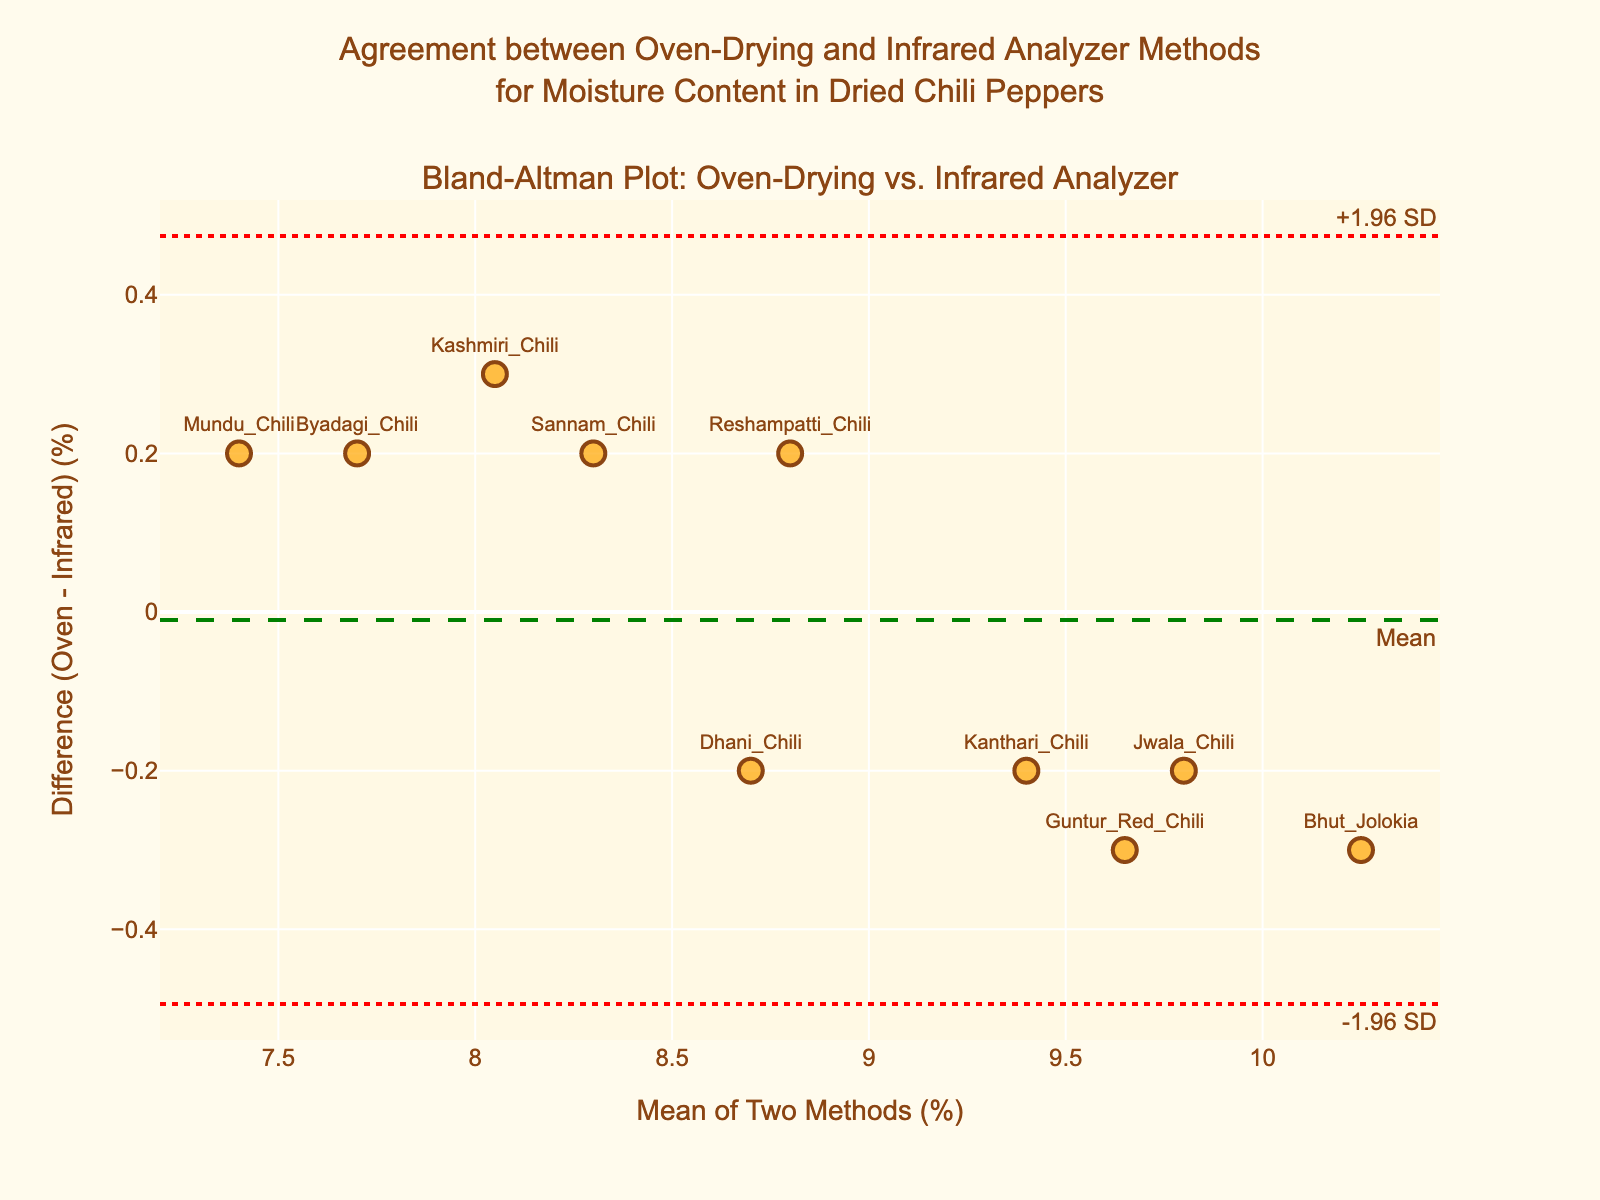What is the main title of the plot? The main title is usually placed at the top center of the plot and summarizes the content in a few words.
Answer: Agreement between Oven-Drying and Infrared Analyzer Methods for Moisture Content in Dried Chili Peppers What do the horizontal dashed and dotted lines represent in the plot? The horizontal dashed line represents the mean difference between two methods, and the dotted lines represent the limits of agreement (±1.96 standard deviations from the mean difference).
Answer: Mean difference and limits of agreement How many samples were measured in the plot? Counting the number of markers on the plot gives the total number of samples measured.
Answer: 10 What is the range of the x-axis? The range of the x-axis can be determined by observing the minimum and maximum values marked.
Answer: Approximately 7.4 to 10.2 Which sample has the largest positive difference between the Oven-Drying and Infrared Analyzer methods? By looking at the data points, the sample with the highest position along the y-axis corresponds to the largest positive difference.
Answer: Bhut Jolokia Which sample has the largest negative difference between the two methods? By identifying the lowest point on the y-axis, we find the sample with the largest negative difference.
Answer: Kashmiri Chili What is the average of the mean values for the samples? Sum the mean values of all samples and divide by the number of samples to find the average mean value.
Answer: (8.05 + 9.65 + 7.7 + 10.25 + 8.8 + 9.4 + 7.4 + 8.7 + 9.8 + 8.3) / 10 = 8.905 Is there any sample that lies outside the limits of agreement? Points outside the dotted lines are outside the limits of agreement. Check each point's position regarding these lines.
Answer: No How do the differences generally trend with the increasing mean moisture content? By observing the scatter plot, we can analyze if the differences increase, decrease, or stay the same with changing mean moisture content.
Answer: No clear trend What color and style are used to plot the mean difference line? By observing the plot, we can identify the color and style used for the mean difference line.
Answer: Green dashed line 